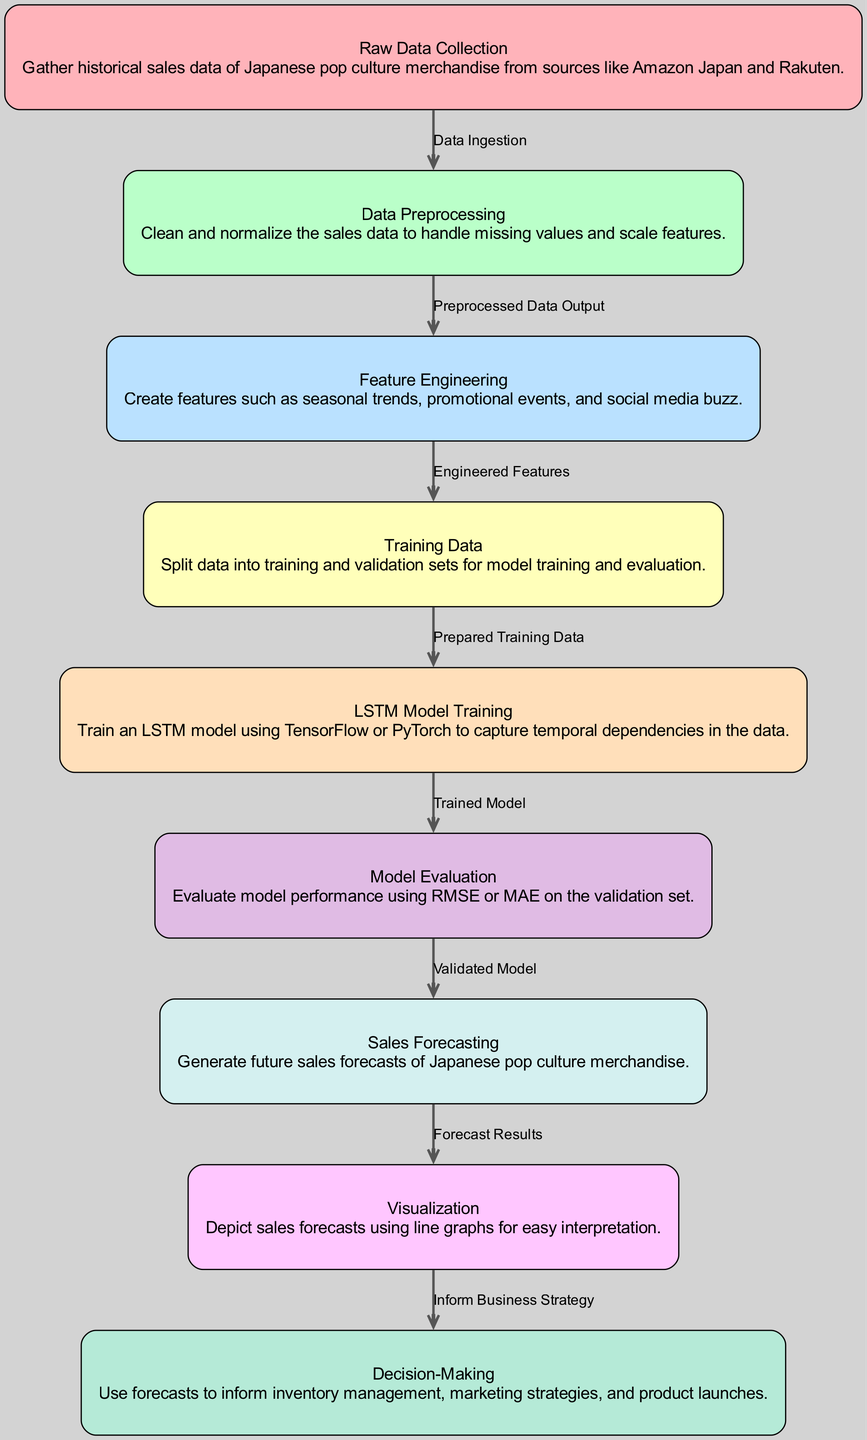What is the first step in the diagram? The first step is "Raw Data Collection", which is identified as node 1. It describes the initial action of gathering historical sales data.
Answer: Raw Data Collection How many nodes are present in the diagram? The diagram has a total of 9 nodes, each representing a specific step in the time series forecasting process.
Answer: 9 What does the edge between node 2 and node 3 represent? The edge between node 2 ("Data Preprocessing") and node 3 ("Feature Engineering") is labeled "Preprocessed Data Output", indicating the flow of data after preprocessing.
Answer: Preprocessed Data Output Which node generates future sales forecasts? Node 7, titled "Sales Forecasting", is responsible for generating the forecasts for future sales based on the trained model.
Answer: Sales Forecasting What is the purpose of the "Visualization" node? The "Visualization" node (node 8) is used to depict the sales forecasts in a line graph for easier interpretation, as stated in its description.
Answer: Depict sales forecasts How does the process move from model evaluation to sales forecasting? The process moves from "Model Evaluation" (node 6) to "Sales Forecasting" (node 7) through the validation of the model, ensuring that the trained model is ready to generate forecasts.
Answer: Validated Model What is the last node in the diagram? The last node is "Decision-Making", which utilizes the forecasts to inform various business strategies.
Answer: Decision-Making Which feature is engineered to reflect promotional events? The feature engineered to reflect promotional events is part of node 3, "Feature Engineering", focusing on capturing the effects of social trends on sales.
Answer: Promotional events What metric is used to evaluate the model's performance? The model is evaluated using metrics such as RMSE (Root Mean Square Error) or MAE (Mean Absolute Error) as stated in node 6, "Model Evaluation".
Answer: RMSE or MAE 